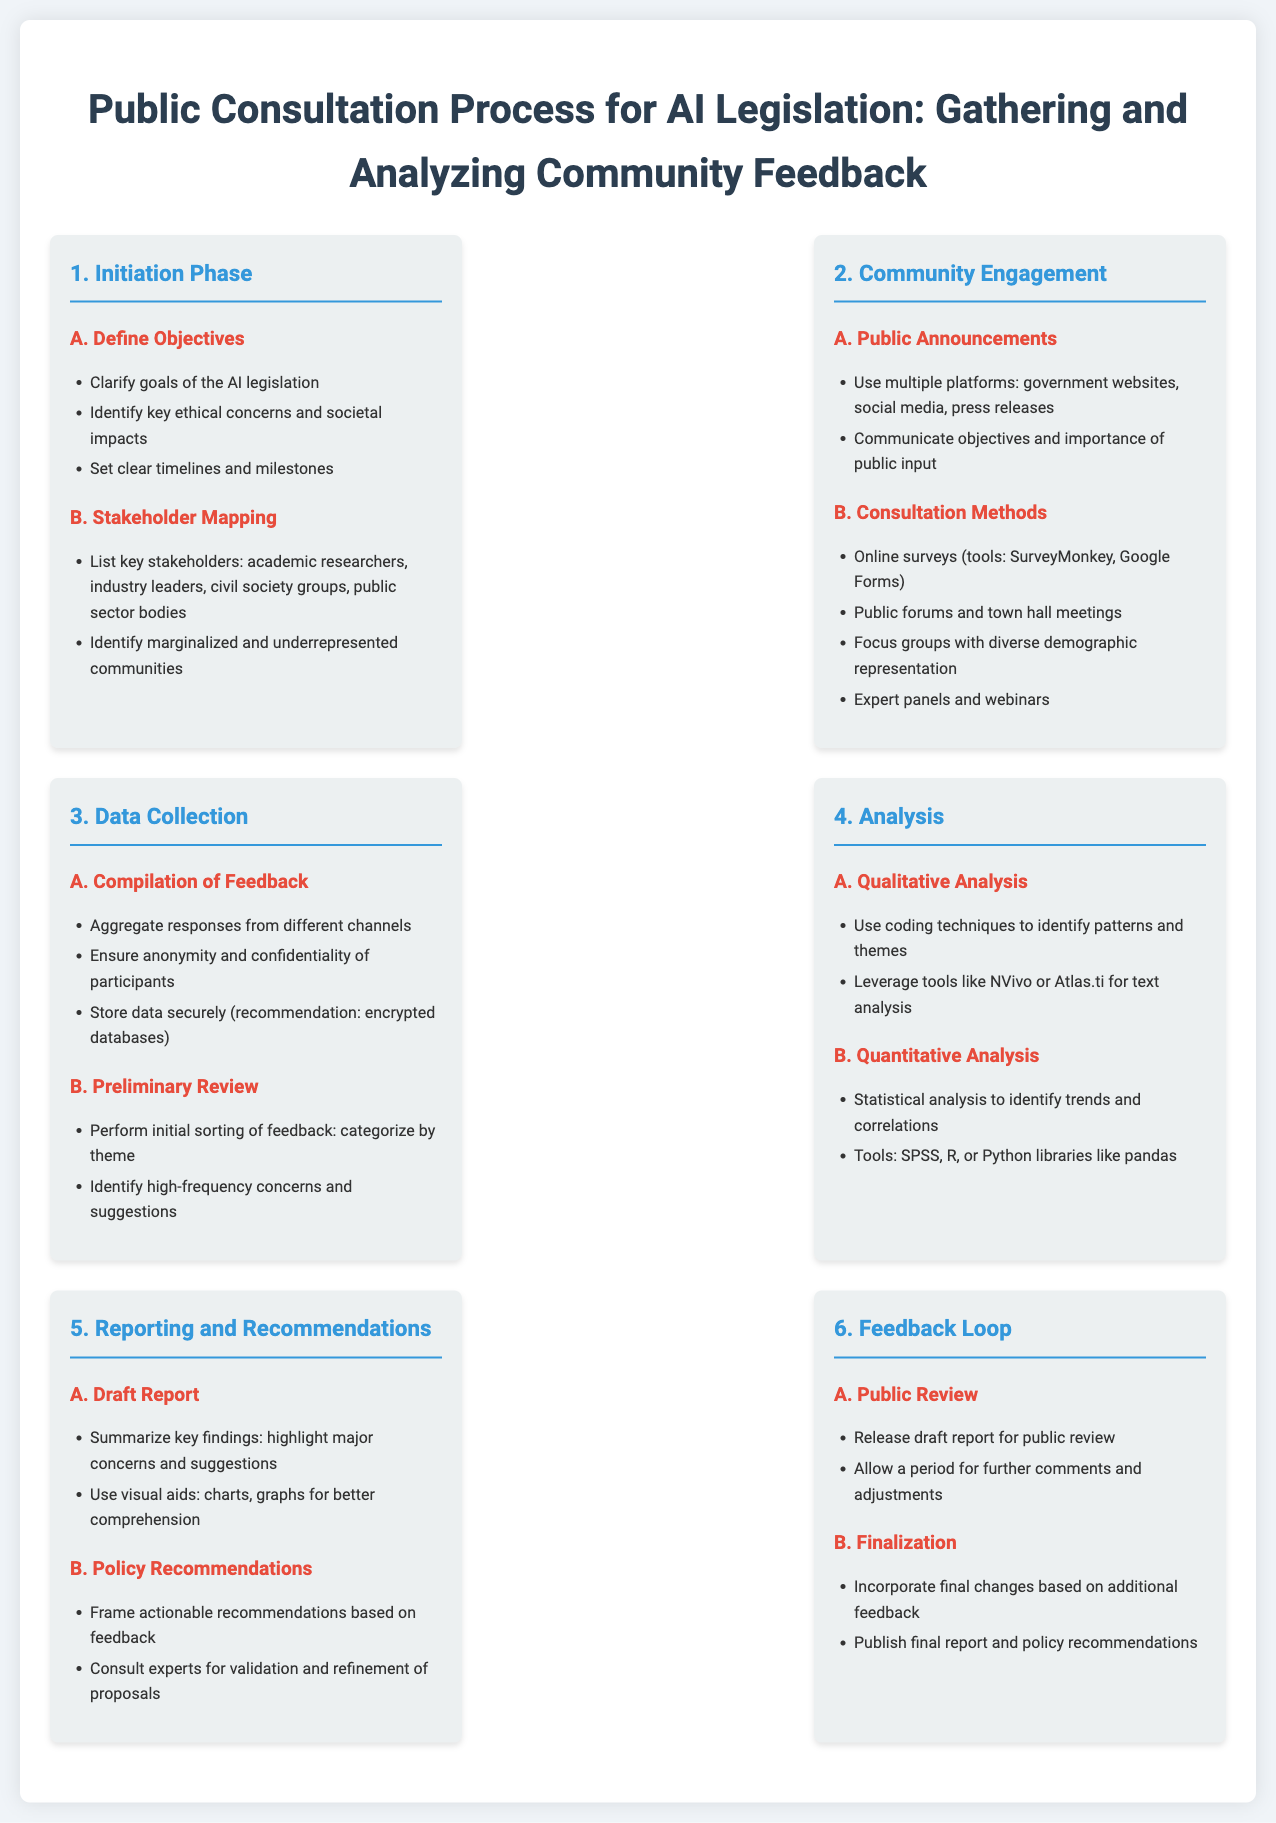what is the first step in the public consultation process? The first step outlined in the infographic is the "Initiation Phase."
Answer: Initiation Phase how many stakeholder categories are mentioned? The document lists two categories: "key stakeholders" and "marginalized and underrepresented communities."
Answer: Two what methods are suggested for community engagement? Various methods include online surveys, public forums, focus groups, and expert panels.
Answer: Online surveys, public forums, focus groups, expert panels what is one tool recommended for qualitative analysis? NVivo is one of the tools mentioned for qualitative analysis in the document.
Answer: NVivo what must be incorporated during the finalization phase? The final report must incorporate changes based on additional feedback received during the public review.
Answer: Changes based on feedback 